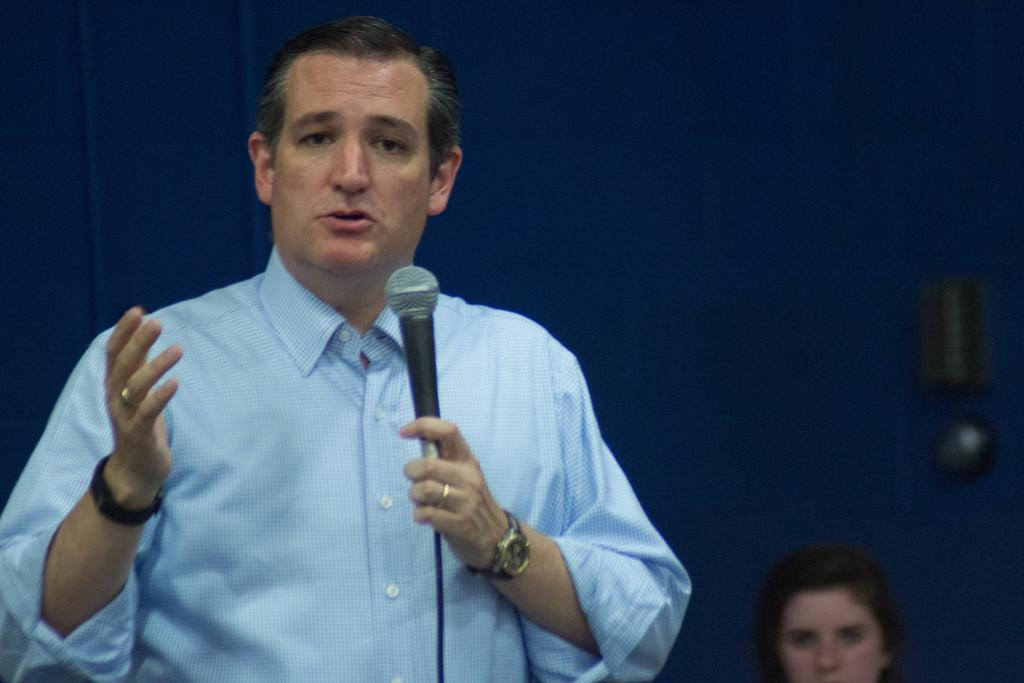Who is present in the image? There is a man and a woman in the image. What is the man doing in the image? The man is talking with the help of a microphone. How is the woman positioned in the image? The woman is seated. What type of jeans is the visitor wearing in the image? There is no visitor mentioned in the image, and therefore no one is wearing jeans. 